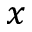Convert formula to latex. <formula><loc_0><loc_0><loc_500><loc_500>x</formula> 